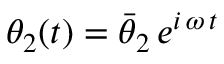<formula> <loc_0><loc_0><loc_500><loc_500>\theta _ { 2 } ( t ) = \bar { \theta } _ { 2 } \, e ^ { i \, \omega \, t }</formula> 